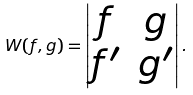Convert formula to latex. <formula><loc_0><loc_0><loc_500><loc_500>W ( f , g ) = \begin{vmatrix} f & g \\ f ^ { \prime } & g ^ { \prime } \end{vmatrix} .</formula> 